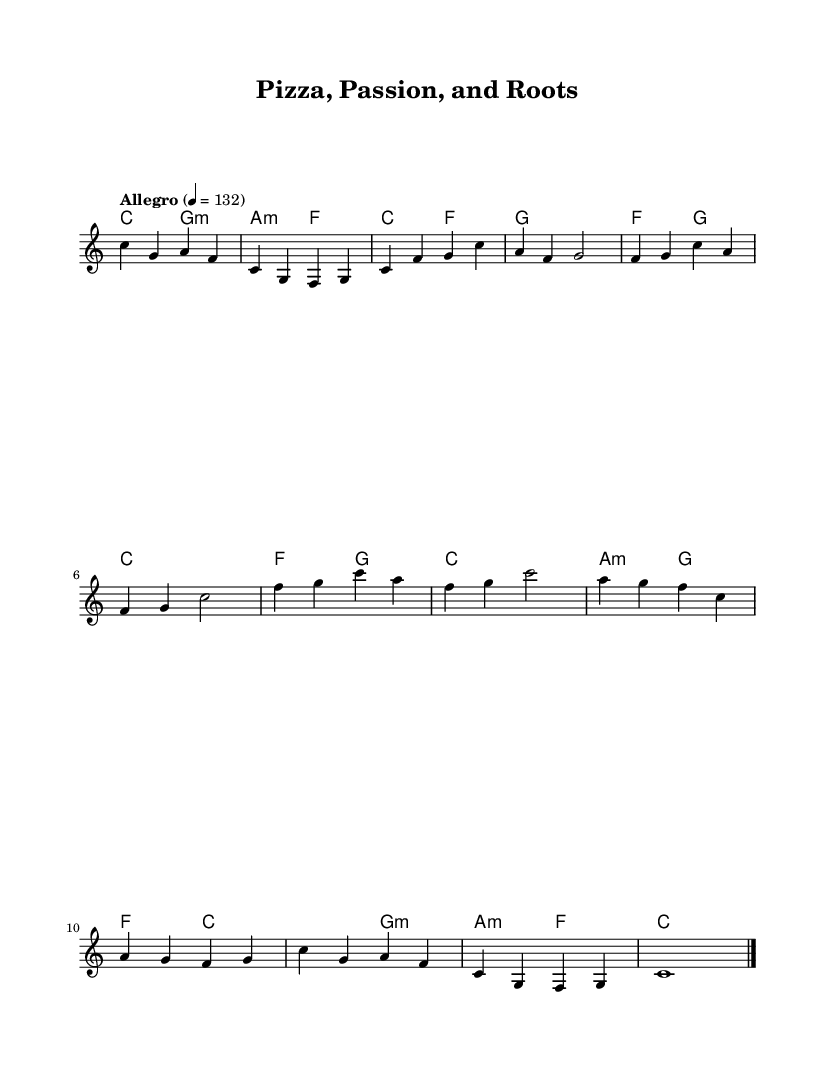What is the key signature of this music? The key signature is indicated by the first set of symbols in the sheet music, which shows no sharps or flats. This corresponds to C major.
Answer: C major What is the time signature of this music? The time signature is found at the beginning of the music sheet, where it shows a "4/4" symbol. This indicates that there are 4 beats per measure, and a quarter note gets one beat.
Answer: 4/4 What is the tempo marked in the piece? The tempo is found in the marking below the title, which states “Allegro” followed by the number "132". This indicates a fast-paced tempo of 132 beats per minute.
Answer: 132 How many measures are in the chorus section? The chorus is repeated twice in the structure of the music. There are a total of 4 measures in each repeat, leading to 8 measures overall for the chorus section.
Answer: 8 What chord accompanies the melody in the outro? The outro shows a sequence of chords listed below the melody notes. The last few measures indicate C major and A minor chords accompanying the final melody.
Answer: C and A minor How does the bridge contrast with the verse? The bridge section shows a different chord progression and melody contour than the verse. The melody in the bridge features notes like A, G, and F, while the verse is characterized by C, F, and G notes prominently. This stark contrast typically provides a change of mood or intensity within the song structure.
Answer: Bridge contrasts with verse What is the primary theme celebrated in this anthem? While this is not directly stated in the music sheet, the title "Pizza, Passion, and Roots" suggests a theme celebrating Italian-American heritage and culture, which is commonly reflected in upbeat rock anthems.
Answer: Heritage and culture 